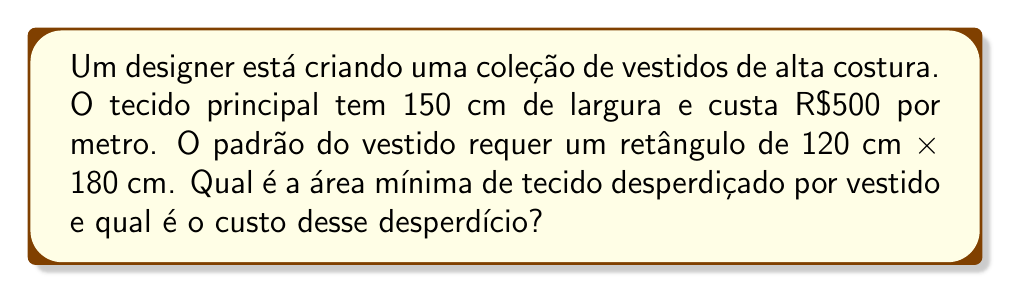Solve this math problem. 1) Primeiro, calculamos a área total do tecido necessário:
   $$A_{total} = 120 \text{ cm} \times 180 \text{ cm} = 21600 \text{ cm}^2$$

2) A largura do tecido é 150 cm, então precisamos determinar o comprimento mínimo necessário:
   $$\text{Comprimento} = \frac{180 \text{ cm}}{150 \text{ cm}} \times 150 \text{ cm} = 180 \text{ cm}$$

3) A área do tecido comprado é:
   $$A_{comprado} = 150 \text{ cm} \times 180 \text{ cm} = 27000 \text{ cm}^2$$

4) A área desperdiçada é a diferença entre a área comprada e a área necessária:
   $$A_{desperdiçada} = 27000 \text{ cm}^2 - 21600 \text{ cm}^2 = 5400 \text{ cm}^2$$

5) Convertendo para metros quadrados:
   $$5400 \text{ cm}^2 = 0.54 \text{ m}^2$$

6) O custo por metro quadrado do tecido é:
   $$\text{Custo por m}^2 = \frac{\text{R\$}500}{1.5 \text{ m}} = \text{R\$}333.33 \text{ por m}^2$$

7) O custo do tecido desperdiçado é:
   $$\text{Custo do desperdício} = 0.54 \text{ m}^2 \times \text{R\$}333.33/\text{m}^2 = \text{R\$}180$$
Answer: 0.54 m²; R$180 